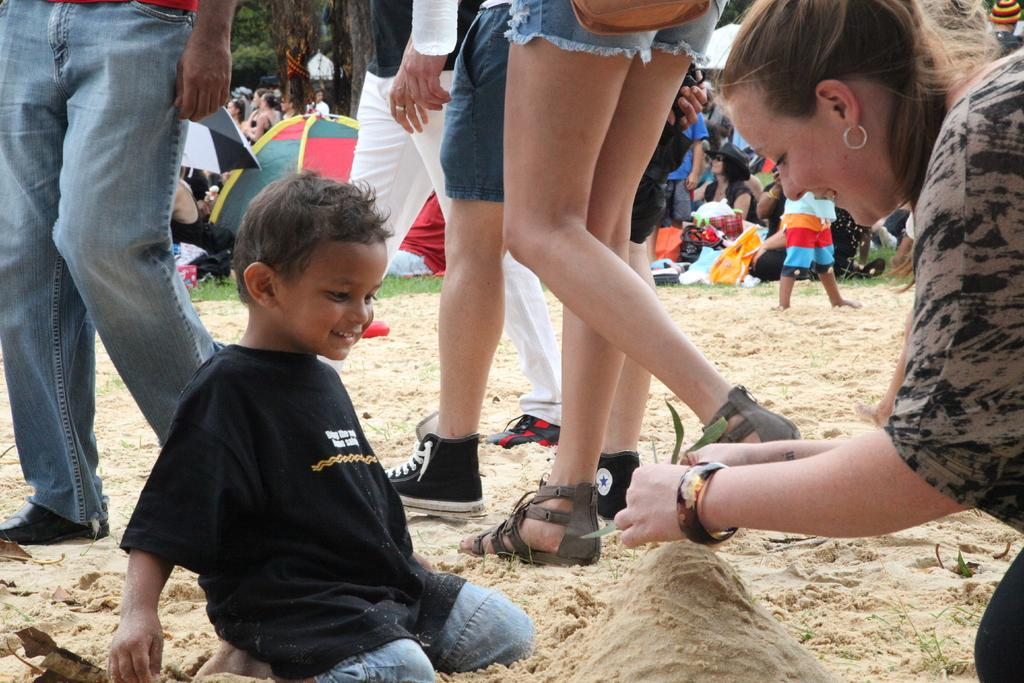Who are the two people sitting on the sand in the image? There is a lady and a boy sitting on the sand in the center of the image. What can be seen in the background of the image? There are people, tents, an umbrella, and trees in the background of the image. How many eyes does the rat have in the image? There is no rat present in the image, so it is not possible to determine the number of eyes it might have. 